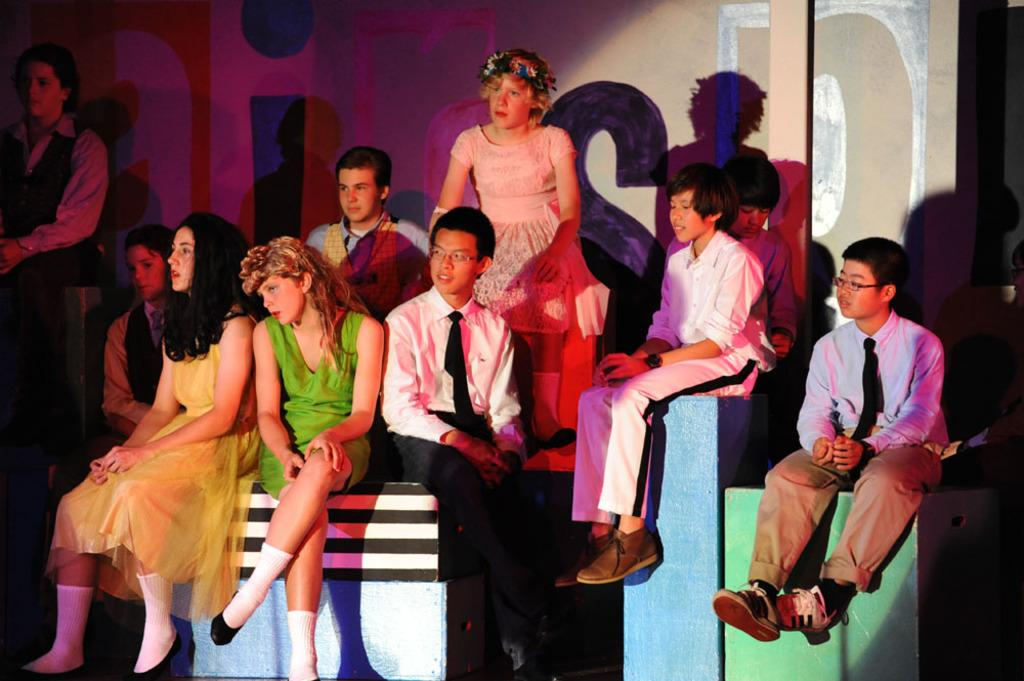What are the people in the image doing? The people in the image are sitting on objects. Can you describe the background of the image? There is a wall with text in the background of the image. What type of connection is causing trouble for the people in the image? There is no indication of any connection or trouble in the image; it simply shows people sitting on objects with a wall and text in the background. 